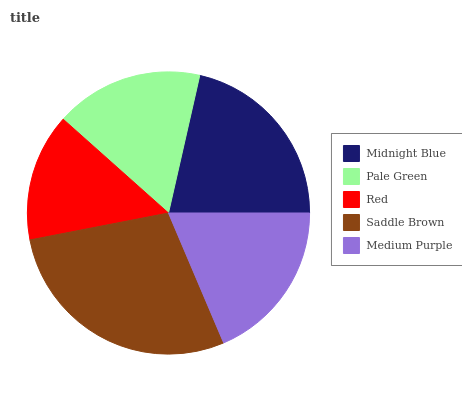Is Red the minimum?
Answer yes or no. Yes. Is Saddle Brown the maximum?
Answer yes or no. Yes. Is Pale Green the minimum?
Answer yes or no. No. Is Pale Green the maximum?
Answer yes or no. No. Is Midnight Blue greater than Pale Green?
Answer yes or no. Yes. Is Pale Green less than Midnight Blue?
Answer yes or no. Yes. Is Pale Green greater than Midnight Blue?
Answer yes or no. No. Is Midnight Blue less than Pale Green?
Answer yes or no. No. Is Medium Purple the high median?
Answer yes or no. Yes. Is Medium Purple the low median?
Answer yes or no. Yes. Is Pale Green the high median?
Answer yes or no. No. Is Red the low median?
Answer yes or no. No. 